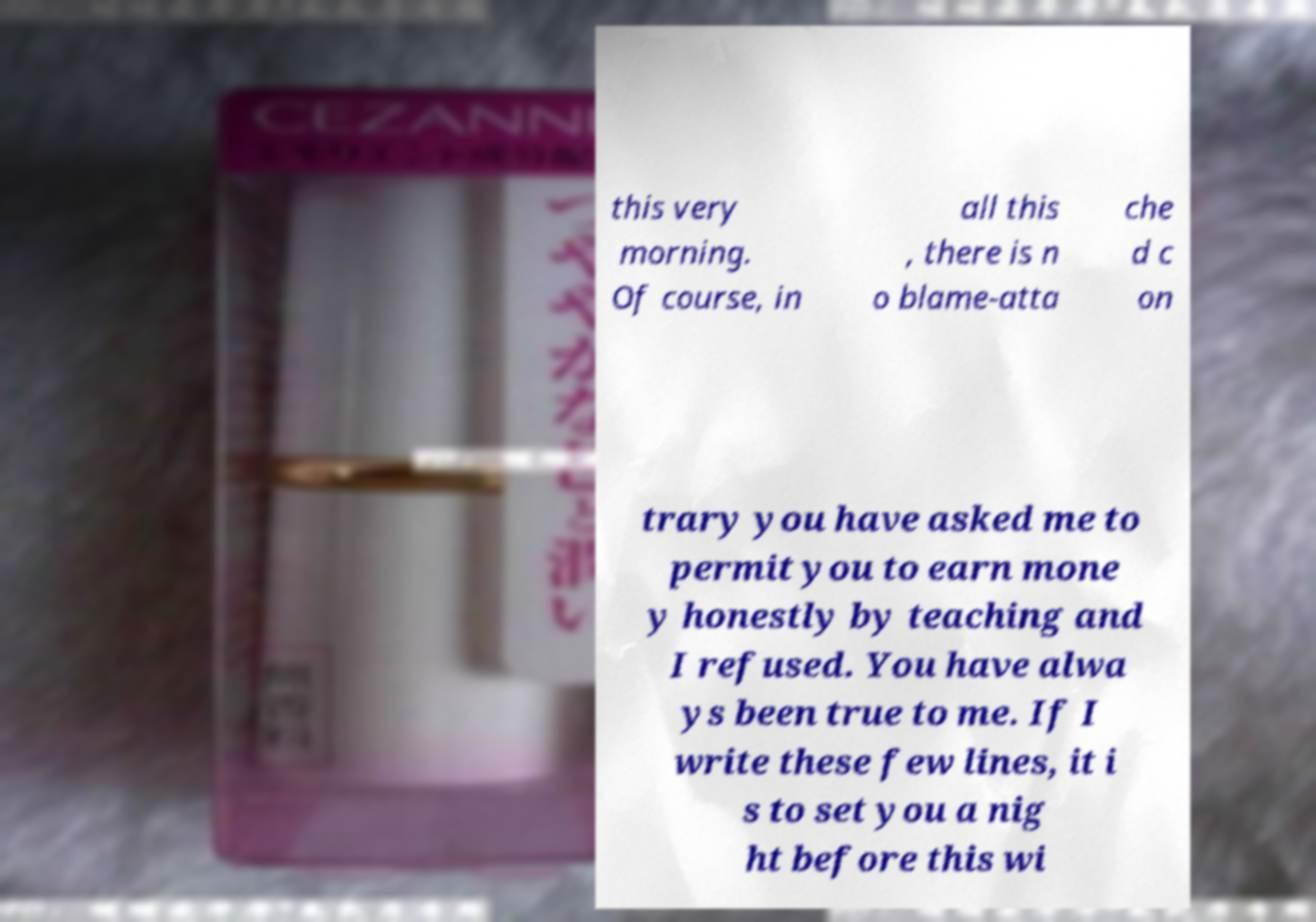Can you read and provide the text displayed in the image?This photo seems to have some interesting text. Can you extract and type it out for me? this very morning. Of course, in all this , there is n o blame-atta che d c on trary you have asked me to permit you to earn mone y honestly by teaching and I refused. You have alwa ys been true to me. If I write these few lines, it i s to set you a nig ht before this wi 